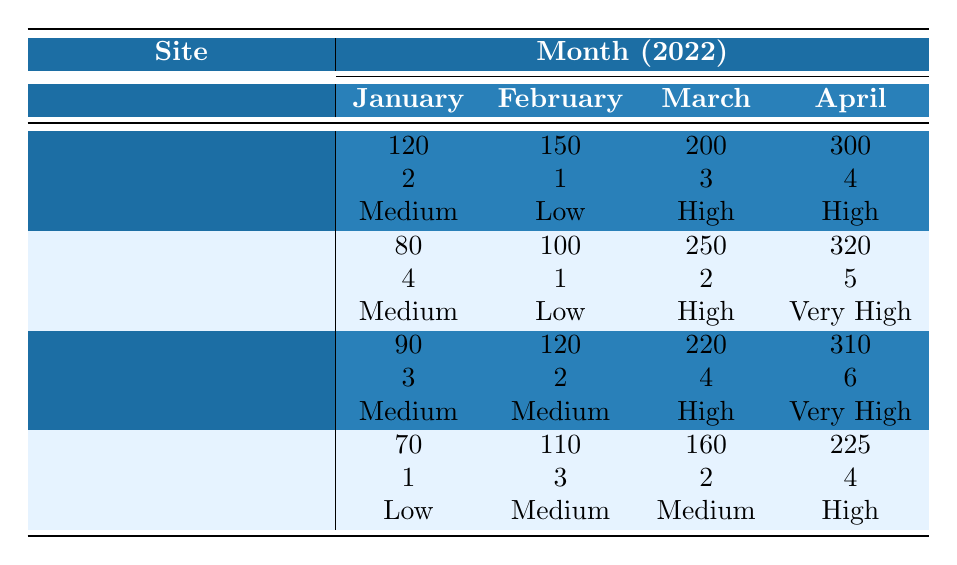What was the total number of visitors to Skien Parish in April 2022? In April 2022, Skien Parish had 300 visitors.
Answer: 300 How many events were held at St. Michael Church in March 2022? In March 2022, St. Michael Church held 2 events.
Answer: 2 What was the engagement level at the Church of Norway in January 2022? The Church of Norway had a medium engagement level in January 2022.
Answer: Medium Which site had the highest number of visitors in February 2022? St. Michael Church had the highest number of visitors in February 2022 with 100 visitors.
Answer: St. Michael Church How many more visitors did Skien Baptist Church have in April than in January 2022? In April 2022, Skien Baptist Church had 225 visitors, and in January, it had 70 visitors. The difference is 225 - 70 = 155.
Answer: 155 What is the average number of visitors for Skien Church of Norway across all four months? The total number of visitors for all four months is 90 + 120 + 220 + 310 = 740. Dividing by 4 gives an average of 740 / 4 = 185.
Answer: 185 Did the engagement level for St. Michael Church improve from January to April 2022? The engagement level changed from medium in January to very high in April, so it did improve.
Answer: Yes Which church had the highest engagement level overall? St. Michael Church had the highest engagement level in April (Very High), which was the highest among all four months.
Answer: St. Michael Church What was the total number of events held at the Church of Norway in the first quarter of 2022? The events held were 3 in January, 2 in February, and 4 in March. The total is 3 + 2 + 4 = 9 events.
Answer: 9 In which month did Skien Parish see the greatest increase in visitors compared to the previous month? From March to April, Skien Parish saw an increase from 200 to 300 visitors, which is an increase of 100 visitors.
Answer: April 